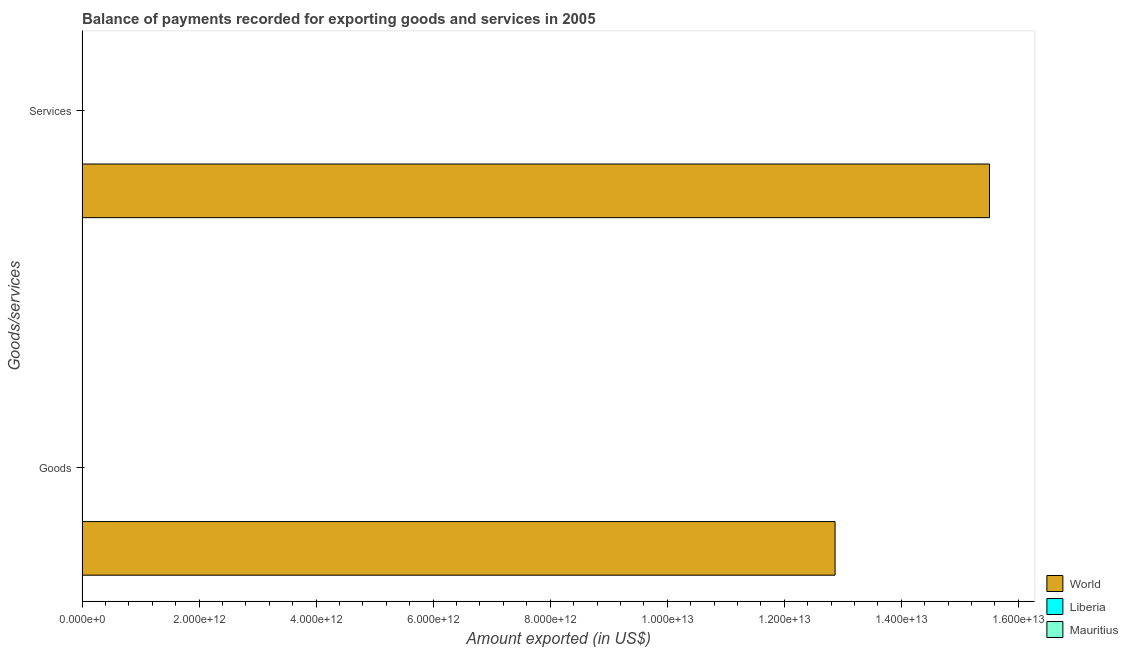How many groups of bars are there?
Offer a very short reply. 2. Are the number of bars per tick equal to the number of legend labels?
Provide a short and direct response. Yes. How many bars are there on the 2nd tick from the top?
Provide a short and direct response. 3. What is the label of the 2nd group of bars from the top?
Provide a succinct answer. Goods. What is the amount of goods exported in World?
Give a very brief answer. 1.29e+13. Across all countries, what is the maximum amount of services exported?
Give a very brief answer. 1.55e+13. Across all countries, what is the minimum amount of goods exported?
Give a very brief answer. 3.46e+08. In which country was the amount of services exported minimum?
Provide a short and direct response. Liberia. What is the total amount of goods exported in the graph?
Offer a very short reply. 1.29e+13. What is the difference between the amount of services exported in Mauritius and that in World?
Give a very brief answer. -1.55e+13. What is the difference between the amount of services exported in Mauritius and the amount of goods exported in World?
Your answer should be very brief. -1.29e+13. What is the average amount of services exported per country?
Make the answer very short. 5.17e+12. What is the difference between the amount of goods exported and amount of services exported in Liberia?
Give a very brief answer. -9.21e+06. What is the ratio of the amount of goods exported in World to that in Liberia?
Make the answer very short. 3.72e+04. What does the 1st bar from the top in Goods represents?
Offer a terse response. Mauritius. What does the 2nd bar from the bottom in Services represents?
Your answer should be very brief. Liberia. How many bars are there?
Give a very brief answer. 6. What is the difference between two consecutive major ticks on the X-axis?
Offer a very short reply. 2.00e+12. Are the values on the major ticks of X-axis written in scientific E-notation?
Offer a very short reply. Yes. Does the graph contain grids?
Give a very brief answer. No. What is the title of the graph?
Provide a succinct answer. Balance of payments recorded for exporting goods and services in 2005. Does "Trinidad and Tobago" appear as one of the legend labels in the graph?
Give a very brief answer. No. What is the label or title of the X-axis?
Your answer should be compact. Amount exported (in US$). What is the label or title of the Y-axis?
Ensure brevity in your answer.  Goods/services. What is the Amount exported (in US$) in World in Goods?
Give a very brief answer. 1.29e+13. What is the Amount exported (in US$) in Liberia in Goods?
Keep it short and to the point. 3.46e+08. What is the Amount exported (in US$) of Mauritius in Goods?
Your response must be concise. 3.76e+09. What is the Amount exported (in US$) in World in Services?
Provide a short and direct response. 1.55e+13. What is the Amount exported (in US$) in Liberia in Services?
Your answer should be compact. 3.55e+08. What is the Amount exported (in US$) in Mauritius in Services?
Ensure brevity in your answer.  3.90e+09. Across all Goods/services, what is the maximum Amount exported (in US$) in World?
Offer a very short reply. 1.55e+13. Across all Goods/services, what is the maximum Amount exported (in US$) of Liberia?
Make the answer very short. 3.55e+08. Across all Goods/services, what is the maximum Amount exported (in US$) of Mauritius?
Provide a succinct answer. 3.90e+09. Across all Goods/services, what is the minimum Amount exported (in US$) in World?
Keep it short and to the point. 1.29e+13. Across all Goods/services, what is the minimum Amount exported (in US$) of Liberia?
Your response must be concise. 3.46e+08. Across all Goods/services, what is the minimum Amount exported (in US$) of Mauritius?
Ensure brevity in your answer.  3.76e+09. What is the total Amount exported (in US$) in World in the graph?
Make the answer very short. 2.84e+13. What is the total Amount exported (in US$) of Liberia in the graph?
Provide a short and direct response. 7.00e+08. What is the total Amount exported (in US$) of Mauritius in the graph?
Offer a terse response. 7.66e+09. What is the difference between the Amount exported (in US$) in World in Goods and that in Services?
Your answer should be very brief. -2.64e+12. What is the difference between the Amount exported (in US$) in Liberia in Goods and that in Services?
Keep it short and to the point. -9.21e+06. What is the difference between the Amount exported (in US$) of Mauritius in Goods and that in Services?
Offer a very short reply. -1.43e+08. What is the difference between the Amount exported (in US$) of World in Goods and the Amount exported (in US$) of Liberia in Services?
Keep it short and to the point. 1.29e+13. What is the difference between the Amount exported (in US$) of World in Goods and the Amount exported (in US$) of Mauritius in Services?
Give a very brief answer. 1.29e+13. What is the difference between the Amount exported (in US$) of Liberia in Goods and the Amount exported (in US$) of Mauritius in Services?
Offer a terse response. -3.55e+09. What is the average Amount exported (in US$) of World per Goods/services?
Offer a terse response. 1.42e+13. What is the average Amount exported (in US$) in Liberia per Goods/services?
Your response must be concise. 3.50e+08. What is the average Amount exported (in US$) in Mauritius per Goods/services?
Provide a succinct answer. 3.83e+09. What is the difference between the Amount exported (in US$) in World and Amount exported (in US$) in Liberia in Goods?
Your answer should be compact. 1.29e+13. What is the difference between the Amount exported (in US$) of World and Amount exported (in US$) of Mauritius in Goods?
Offer a terse response. 1.29e+13. What is the difference between the Amount exported (in US$) of Liberia and Amount exported (in US$) of Mauritius in Goods?
Provide a short and direct response. -3.41e+09. What is the difference between the Amount exported (in US$) of World and Amount exported (in US$) of Liberia in Services?
Make the answer very short. 1.55e+13. What is the difference between the Amount exported (in US$) in World and Amount exported (in US$) in Mauritius in Services?
Your response must be concise. 1.55e+13. What is the difference between the Amount exported (in US$) of Liberia and Amount exported (in US$) of Mauritius in Services?
Your answer should be very brief. -3.54e+09. What is the ratio of the Amount exported (in US$) in World in Goods to that in Services?
Ensure brevity in your answer.  0.83. What is the ratio of the Amount exported (in US$) in Mauritius in Goods to that in Services?
Your response must be concise. 0.96. What is the difference between the highest and the second highest Amount exported (in US$) of World?
Your answer should be very brief. 2.64e+12. What is the difference between the highest and the second highest Amount exported (in US$) of Liberia?
Your answer should be compact. 9.21e+06. What is the difference between the highest and the second highest Amount exported (in US$) of Mauritius?
Provide a succinct answer. 1.43e+08. What is the difference between the highest and the lowest Amount exported (in US$) of World?
Provide a succinct answer. 2.64e+12. What is the difference between the highest and the lowest Amount exported (in US$) of Liberia?
Provide a succinct answer. 9.21e+06. What is the difference between the highest and the lowest Amount exported (in US$) in Mauritius?
Offer a very short reply. 1.43e+08. 